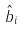Convert formula to latex. <formula><loc_0><loc_0><loc_500><loc_500>\hat { b } _ { i }</formula> 